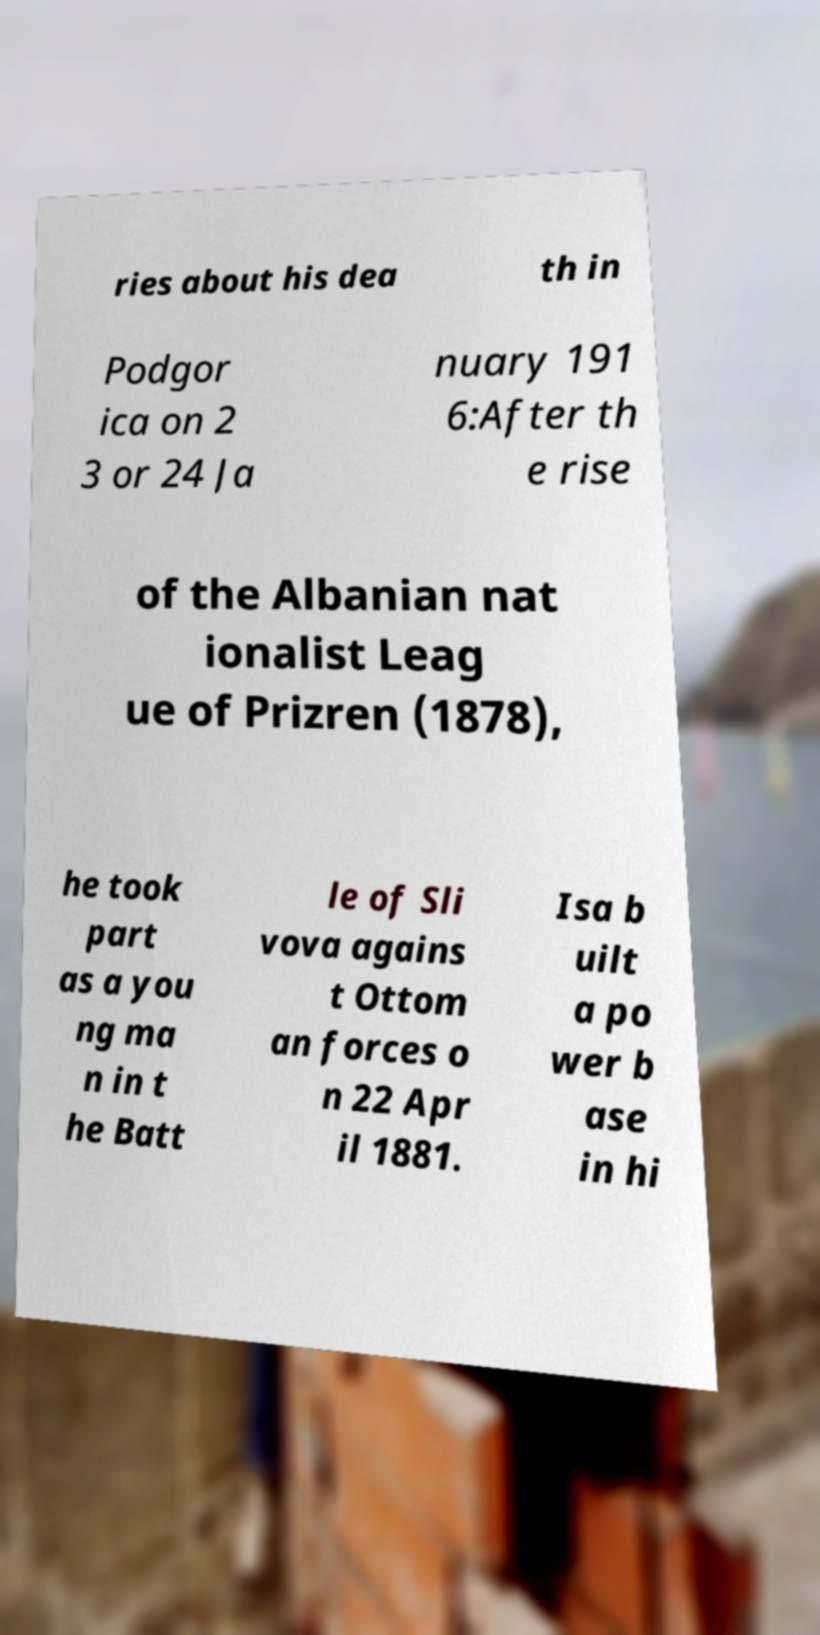There's text embedded in this image that I need extracted. Can you transcribe it verbatim? ries about his dea th in Podgor ica on 2 3 or 24 Ja nuary 191 6:After th e rise of the Albanian nat ionalist Leag ue of Prizren (1878), he took part as a you ng ma n in t he Batt le of Sli vova agains t Ottom an forces o n 22 Apr il 1881. Isa b uilt a po wer b ase in hi 